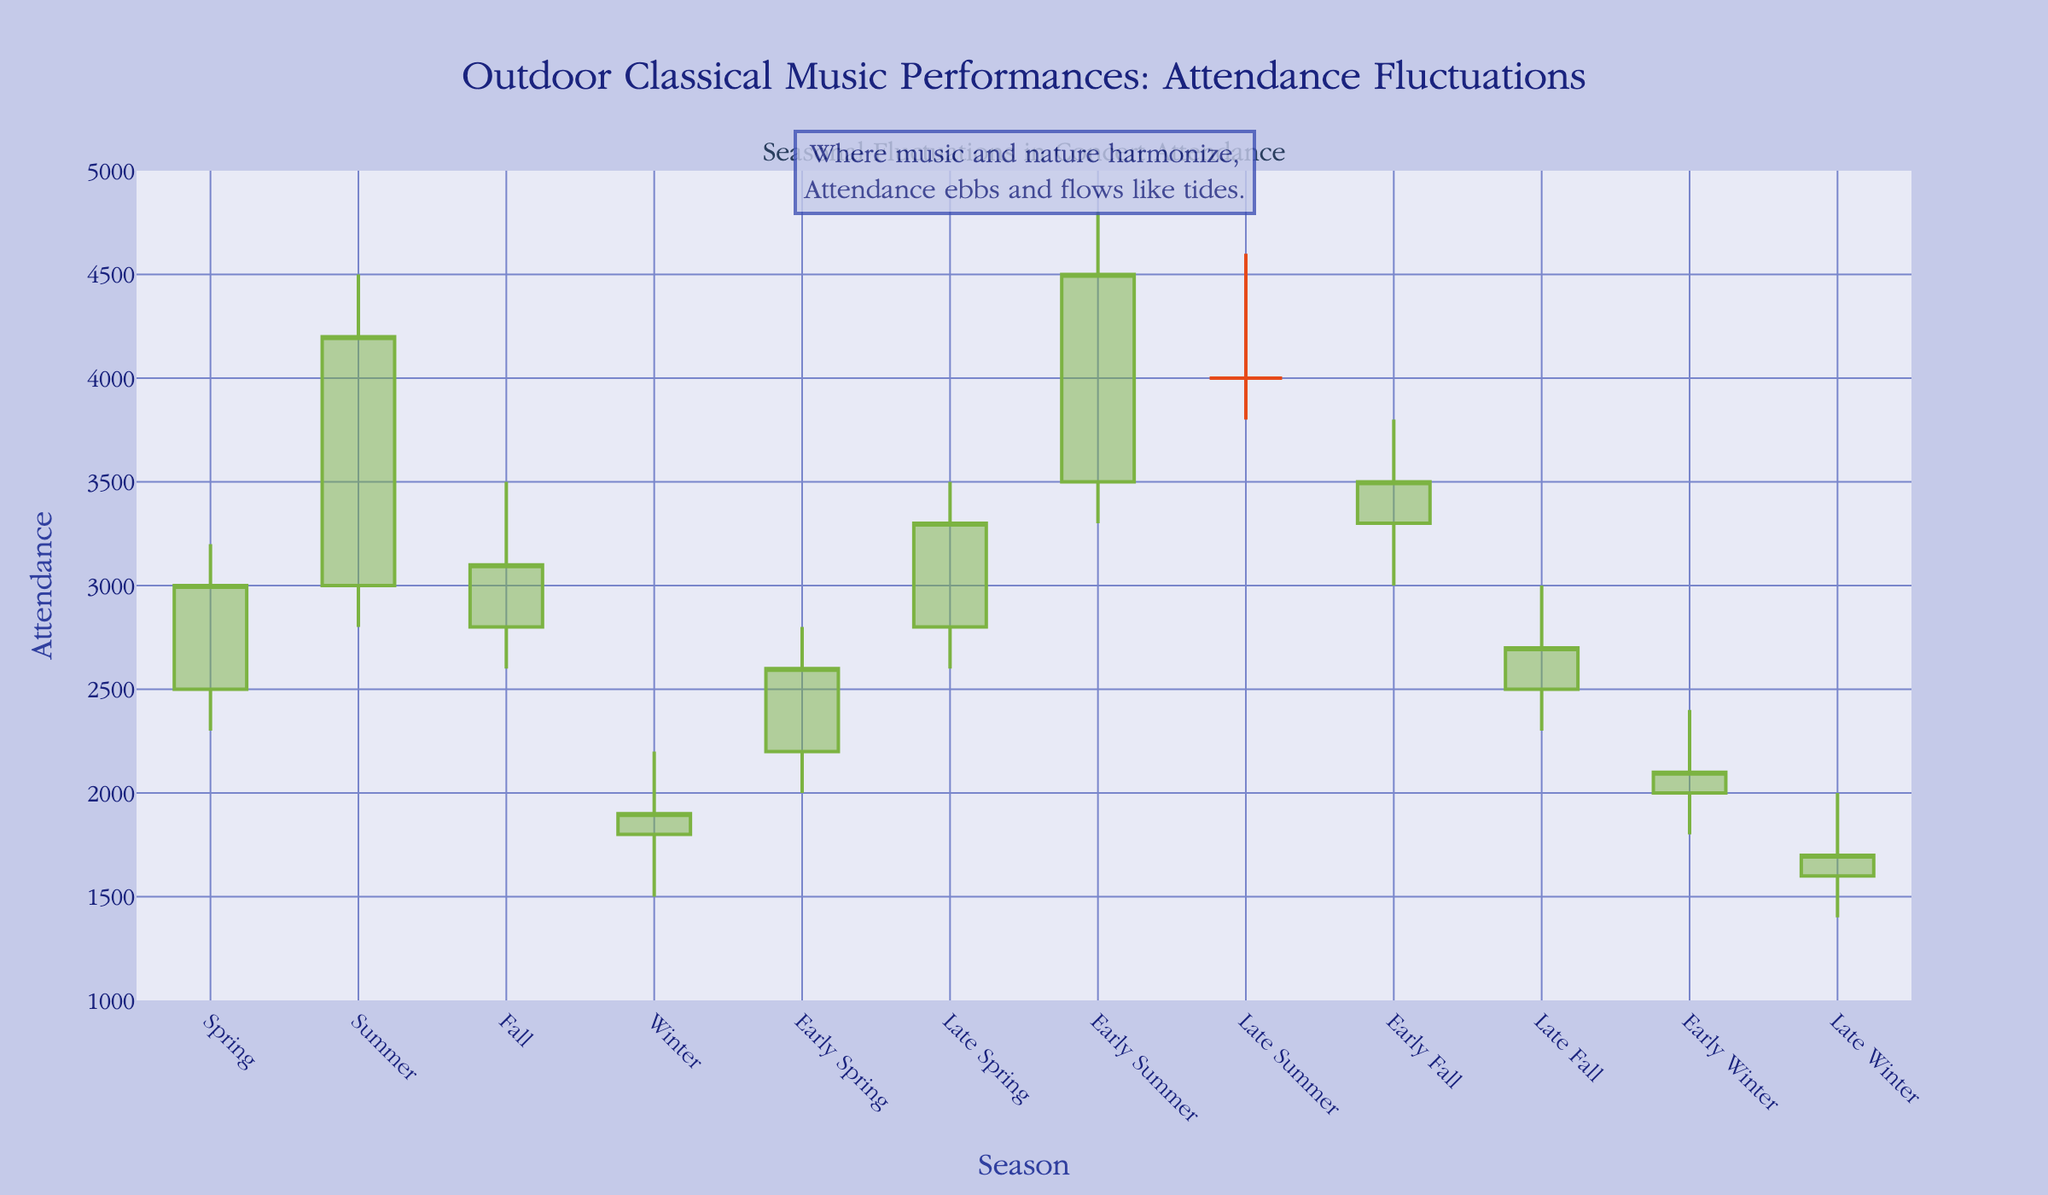What's the title of the chart? The title is usually found at the top of the chart. In this case, it reads "Outdoor Classical Music Performances: Attendance Fluctuations".
Answer: Outdoor Classical Music Performances: Attendance Fluctuations Which season has the highest attendance? The highest attendance is determined by the highest "High" value. Summer has the highest attendance with a "High" value of 4800 in Early Summer.
Answer: Early Summer Which season has the lowest closing attendance? The lowest closing attendance is shown by the lowest "Close" value. Late Winter has the lowest closing attendance with a "Close" value of 1700.
Answer: Late Winter What is the average closing attendance for the Spring seasons combined (Spring, Early Spring, Late Spring)? Add the closing attendance for Spring, Early Spring, and Late Spring, then divide by the number of these seasons: (3000 + 2600 + 3300) / 3 = 2900.
Answer: 2900 Compare the increase in attendance from Early Spring to Late Spring. The increase is calculated by subtracting Early Spring's close from Late Spring's close: 3300 (Late Spring) - 2600 (Early Spring) = 700.
Answer: 700 Which season shows the greatest difference between the high and low attendance? The difference between high and low attendance is found by subtracting the low from the high for each season. Summer has the greatest difference: 4800 - 3300 = 1500.
Answer: Early Summer Is the closing attendance higher in Early Fall or Late Fall? Compare the closing attendance values for Early Fall and Late Fall. Early Fall has a closing value of 3500, and Late Fall has a closing value of 2700.
Answer: Early Fall Identify a season with decreasing attendance and provide its closing attendance. A season with decreasing attendance will have the close value lower than the open value. Winter has decreasing attendance with a closing value of 1900.
Answer: Winter, 1900 What's the range of attendance during Early Winter? The range is calculated by subtracting the low from the high attendance value. For Early Winter, it's 2400 - 1800 = 600.
Answer: 600 